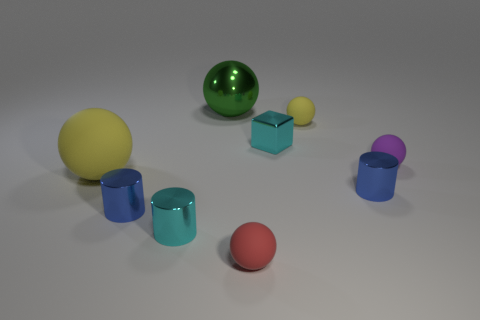What size is the shiny object that is the same color as the tiny block?
Offer a terse response. Small. Are there fewer purple matte things that are in front of the large yellow object than tiny cylinders that are to the right of the tiny cube?
Give a very brief answer. Yes. Are there any big brown matte objects that have the same shape as the green metal thing?
Provide a succinct answer. No. Is the shape of the tiny yellow object the same as the big green metallic thing?
Your answer should be very brief. Yes. What number of tiny objects are red balls or shiny things?
Make the answer very short. 5. Is the number of big green metal objects greater than the number of big shiny cylinders?
Provide a succinct answer. Yes. What is the size of the purple ball that is the same material as the red object?
Provide a short and direct response. Small. Do the shiny block that is in front of the large green object and the cyan object in front of the tiny cyan shiny cube have the same size?
Provide a succinct answer. Yes. What number of objects are either objects left of the tiny cyan block or tiny cylinders?
Ensure brevity in your answer.  6. Is the number of cyan cylinders less than the number of large cylinders?
Give a very brief answer. No. 